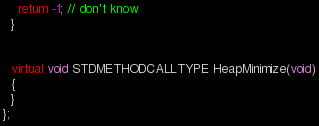Convert code to text. <code><loc_0><loc_0><loc_500><loc_500><_C++_>    return -1; // don't know
  }


  virtual void STDMETHODCALLTYPE HeapMinimize(void)
  {
  }
};
</code> 